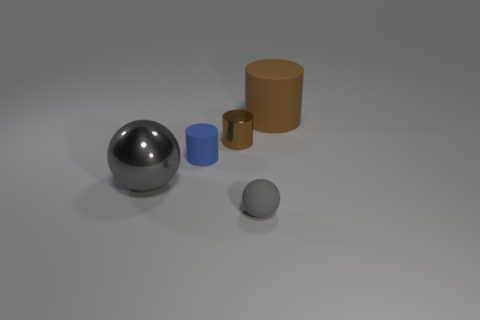Subtract all red cubes. How many brown cylinders are left? 2 Add 5 shiny objects. How many objects exist? 10 Subtract all balls. How many objects are left? 3 Add 1 large balls. How many large balls are left? 2 Add 4 large green matte things. How many large green matte things exist? 4 Subtract 0 yellow cylinders. How many objects are left? 5 Subtract all tiny blue cylinders. Subtract all large purple cylinders. How many objects are left? 4 